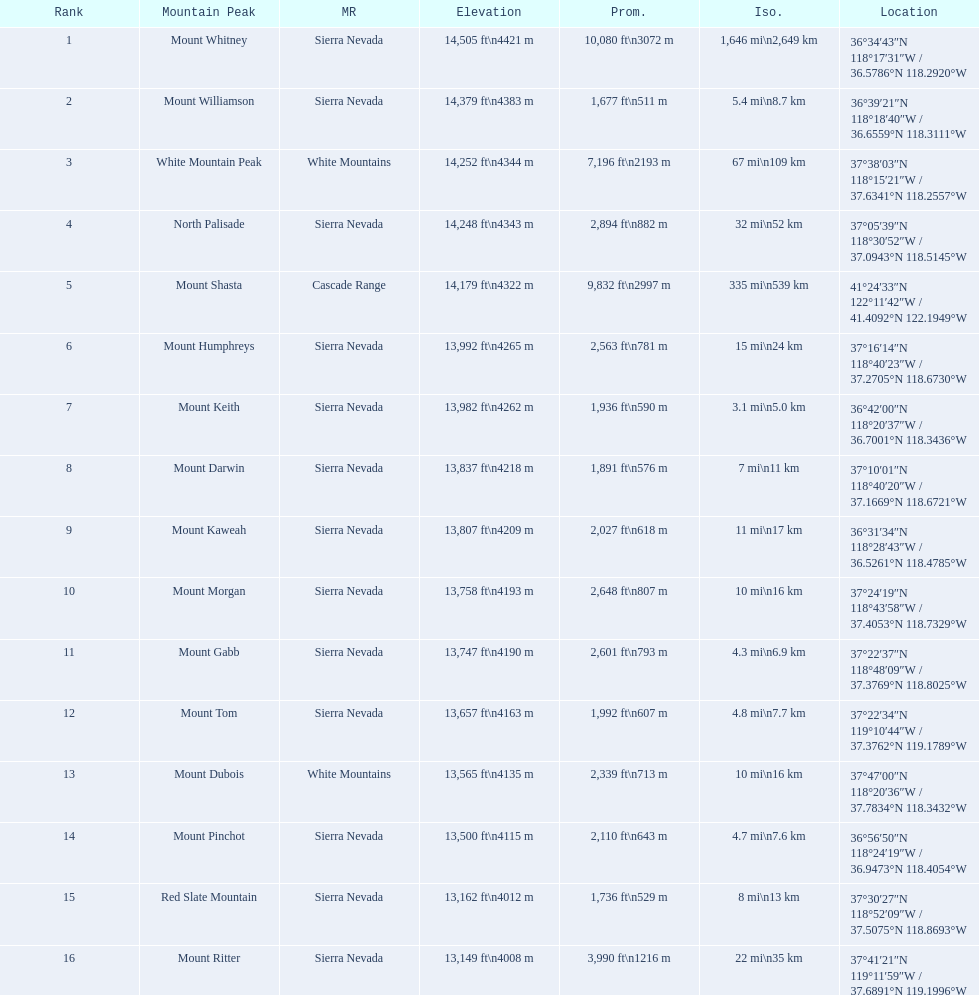What are all of the mountain peaks? Mount Whitney, Mount Williamson, White Mountain Peak, North Palisade, Mount Shasta, Mount Humphreys, Mount Keith, Mount Darwin, Mount Kaweah, Mount Morgan, Mount Gabb, Mount Tom, Mount Dubois, Mount Pinchot, Red Slate Mountain, Mount Ritter. In what ranges are they located? Sierra Nevada, Sierra Nevada, White Mountains, Sierra Nevada, Cascade Range, Sierra Nevada, Sierra Nevada, Sierra Nevada, Sierra Nevada, Sierra Nevada, Sierra Nevada, Sierra Nevada, White Mountains, Sierra Nevada, Sierra Nevada, Sierra Nevada. And which mountain peak is in the cascade range? Mount Shasta. 